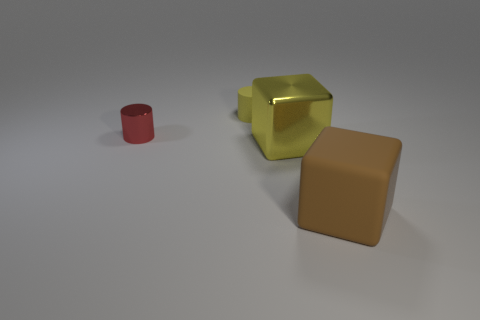Add 1 big shiny objects. How many objects exist? 5 Add 1 purple rubber cylinders. How many purple rubber cylinders exist? 1 Subtract 0 brown balls. How many objects are left? 4 Subtract all yellow blocks. Subtract all big metal things. How many objects are left? 2 Add 3 large yellow things. How many large yellow things are left? 4 